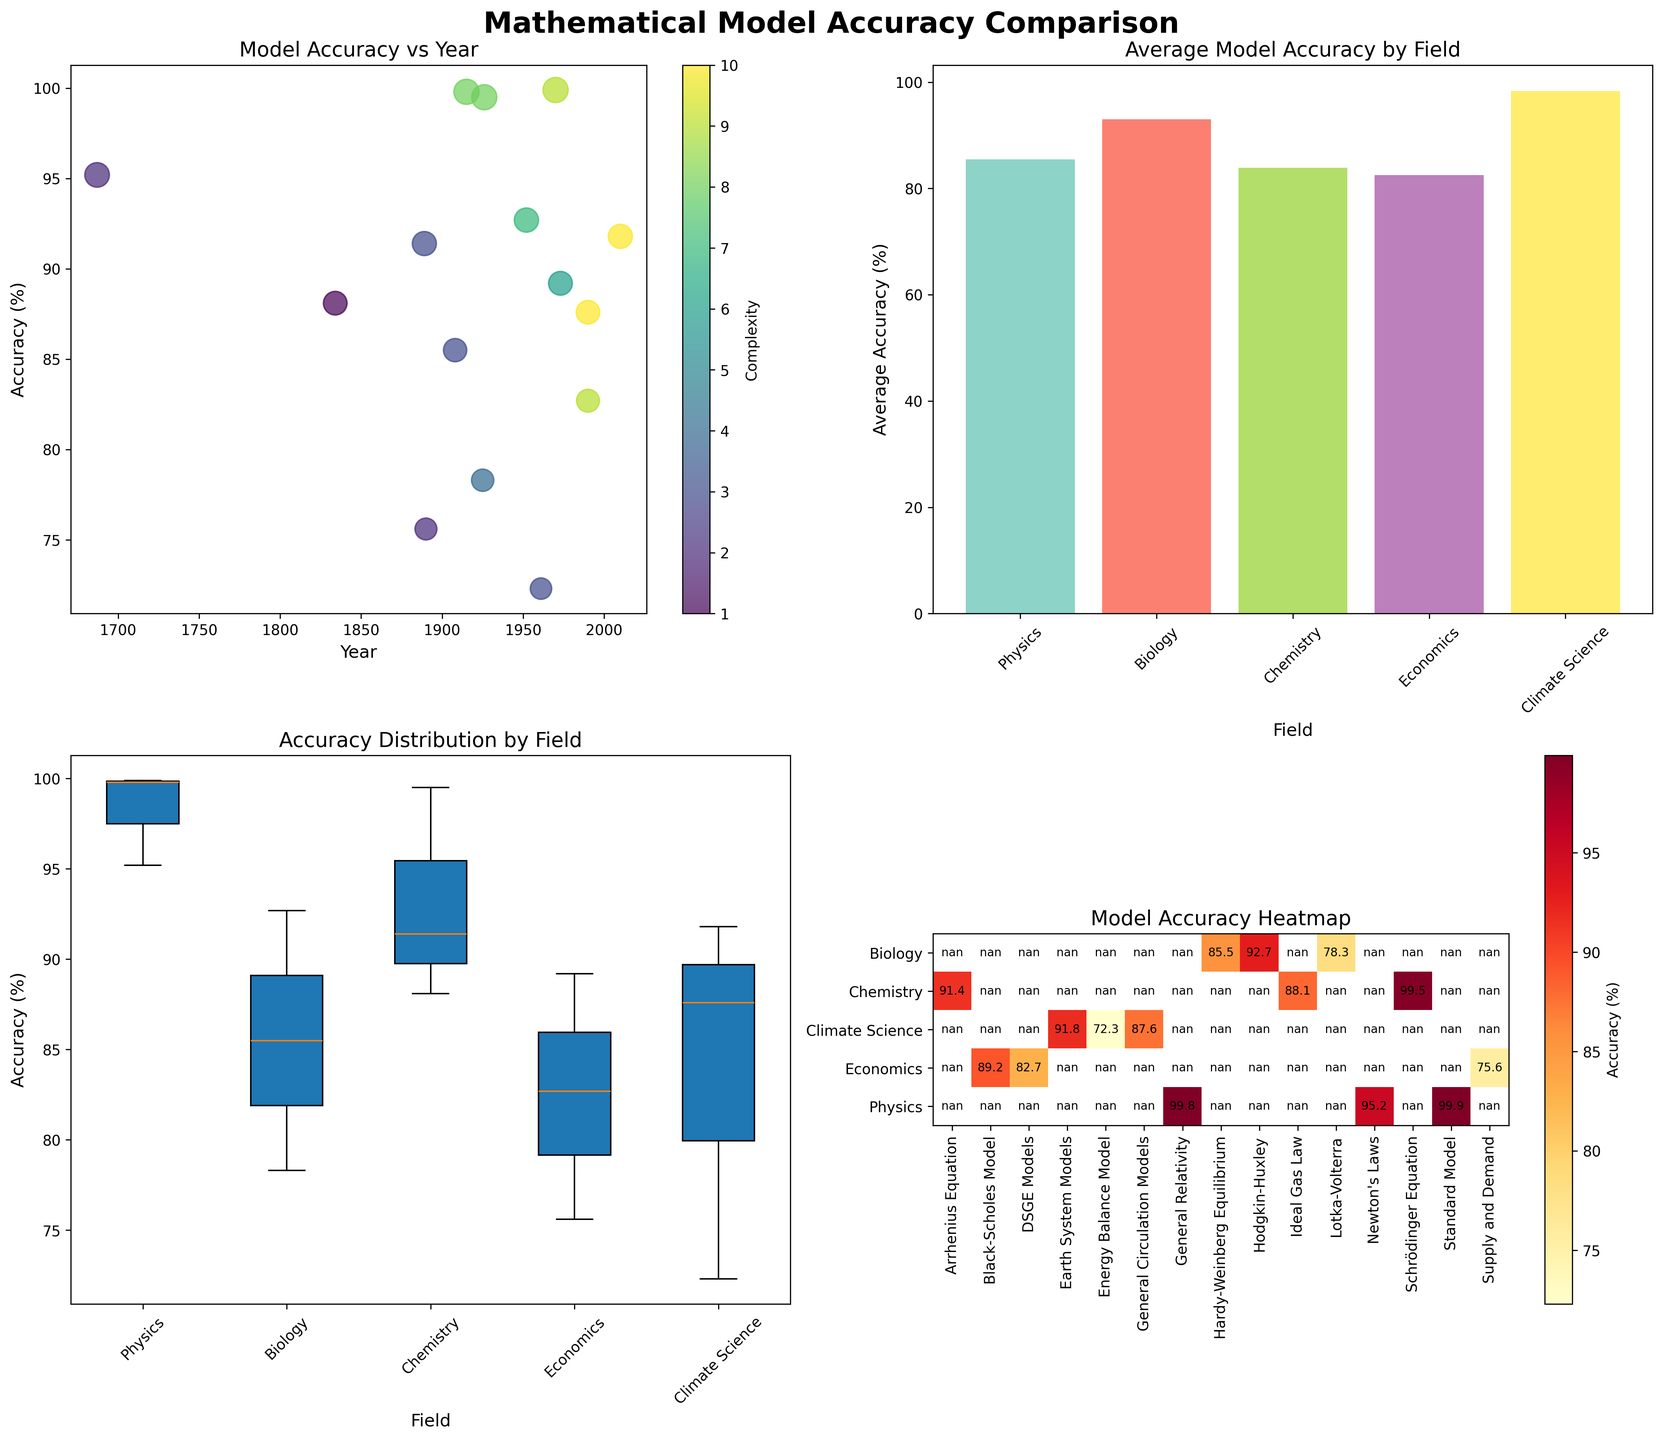What is the title of the overall figure? The title is prominently shown at the top of the figure. It reads "Mathematical Model Accuracy Comparison".
Answer: Mathematical Model Accuracy Comparison How is the color scale used in the scatter plot? The scatter plot uses a color scale to represent the complexity of the models. The colors vary according to the complexity level ranging from low complexity to high complexity, displayed via a color bar on the side.
Answer: Complexity Which field shows the highest average accuracy in the bar plot? The bar plot shows average accuracy values for each field. By looking at the heights of the bars, we can see that Physics has the highest average accuracy.
Answer: Physics How many unique scientific fields are represented in the figure? There are four subplots, each representing different aspects. We see the same fields listed across these subplots, including the heatmap where the field names are displayed. Counting them, we find there are five unique scientific fields: Physics, Biology, Chemistry, Economics, and Climate Science.
Answer: Five What is the model with the highest accuracy in the heatmap subplot? The heatmap shows accuracy values for different models across fields. By finding the highest value in the heatmap, we see that the Standard Model in Physics has the highest accuracy with 99.9%.
Answer: Standard Model What was the accuracy of the Schrödinger Equation model, and in which year was it developed? We can find the Schrödinger Equation model in the heatmap or scatter plot. According to the figure, its accuracy is 99.5% and it was developed in the year 1926.
Answer: 99.5%, 1926 Which field has the widest distribution of accuracies in the box plot? The box plot shows the distribution of accuracies for different fields. By comparing the range of the box and whiskers, we can see that Biology has the widest distribution of accuracies.
Answer: Biology What is the average accuracy of models in Chemistry? From the bar plot showing average accuracies per field, we find the bar corresponding to Chemistry and see its height represents an average accuracy of approximately 93.0%.
Answer: 93.0% Compare the accuracies of General Circulation Models and Energy Balance Models in Climate Science. In the heatmap, we can see both models under Climate Science. The General Circulation Models have an accuracy of 87.6%, while the Energy Balance Models have an accuracy of 72.3%.
Answer: 87.6%, 72.3% In the scatter plot, what is the relationship between the model development year and accuracy? The scatter plot shows model accuracy on the y-axis and development year on the x-axis. Observing the trend, we see that generally, newer models tend to have higher accuracy.
Answer: Newer models higher accuracy 